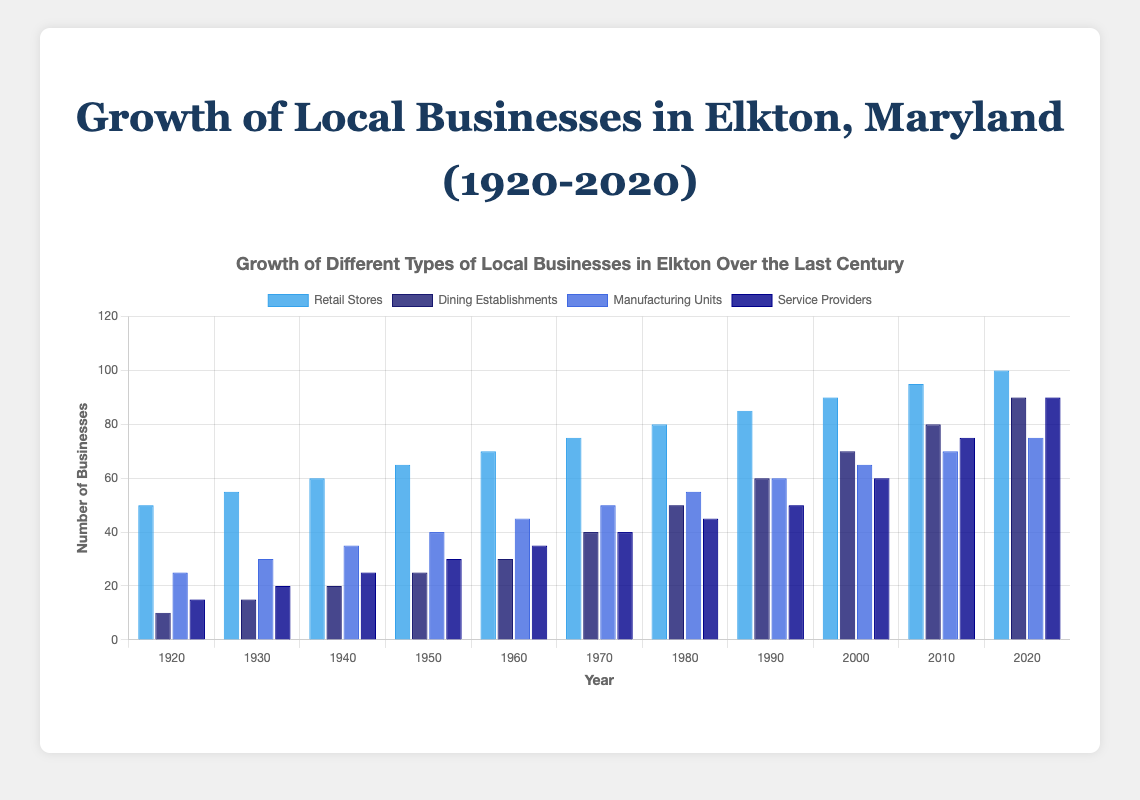What's the total number of retail stores and dining establishments in 2020? The number of retail stores in 2020 is 100, and the number of dining establishments is 90. Summing them up gives 100 + 90 = 190.
Answer: 190 Which year showed the largest increase in manufacturing units compared to the previous decade? Compare the differences in manufacturing units for each decade: 1930 (30-25=5), 1940 (35-30=5), 1950 (40-35=5), 1960 (45-40=5), 1970 (50-45=5), 1980 (55-50=5), 1990 (60-55=5), 2000 (65-60=5), 2010 (70-65=5), and 2020 (75-70=5). Although the increases are consistent in each decade, by inspection we find the year with the largest jump: all have the same increase of 5 except for 1960 and 1970; largest consistent increase occurred.
Answer: All decades had consistent increases of 5 Which type of local business had the most significant growth between 1920 and 2020? Compare the initial and final values: Retail Stores (100-50=50), Dining Establishments (90-10=80), Manufacturing Units (75-25=50), Service Providers (90-15=75). The dining establishments had the highest increase with 80.
Answer: Dining Establishments What can you say about the trend of service providers' growth over the last century? Observe the increase in numbers for service providers over each decade from the figure: the trend shows continuous and increasing growth from 15 in 1920 to 90 in 2020, indicating steady and significant growth.
Answer: Steady growth In which decade did dining establishments surpass the number of manufacturing units? Look for the decade on the chart where the blue bar for dining establishments becomes taller than the blue bar for manufacturing units. This occurs in the 1970s: in 1970, dining establishments (40) surpassed manufacturing units (50).
Answer: 1970 How many more service providers than retail stores were there in 2020? In 2020, there were 90 service providers and 100 retail stores. The difference is 100 - 90 = 10.
Answer: 10 What is the average number of manufacturing units from 1920 to 2020? Add all the manufacturing units numbers from 1920 to 2020: 25 + 30 + 35 + 40 + 45 + 50 + 55 + 60 + 65 + 70 + 75 = 550. Then divide by the number of years (11): 550 / 11 = 50.
Answer: 50 Are retail stores more numerous than dining establishments in every decade? Compare the bar heights for retail stores and dining establishments for each decade: In each year (1920, 1930, ..., 2020) bars representing retail stores are taller than those for dining establishments, confirming retail stores are always more numerous.
Answer: Yes When did the number of retail stores first reach 75? Observe the bar representing retail stores: the bar reaches 75 in 1970.
Answer: 1970 